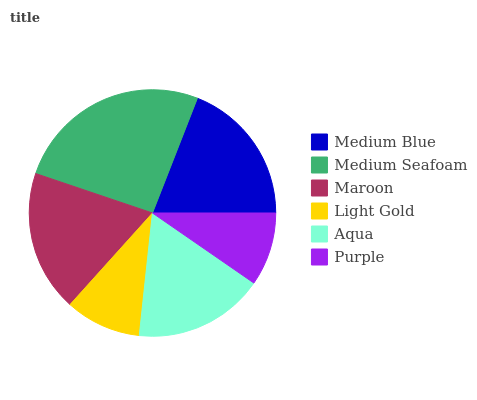Is Purple the minimum?
Answer yes or no. Yes. Is Medium Seafoam the maximum?
Answer yes or no. Yes. Is Maroon the minimum?
Answer yes or no. No. Is Maroon the maximum?
Answer yes or no. No. Is Medium Seafoam greater than Maroon?
Answer yes or no. Yes. Is Maroon less than Medium Seafoam?
Answer yes or no. Yes. Is Maroon greater than Medium Seafoam?
Answer yes or no. No. Is Medium Seafoam less than Maroon?
Answer yes or no. No. Is Maroon the high median?
Answer yes or no. Yes. Is Aqua the low median?
Answer yes or no. Yes. Is Aqua the high median?
Answer yes or no. No. Is Light Gold the low median?
Answer yes or no. No. 